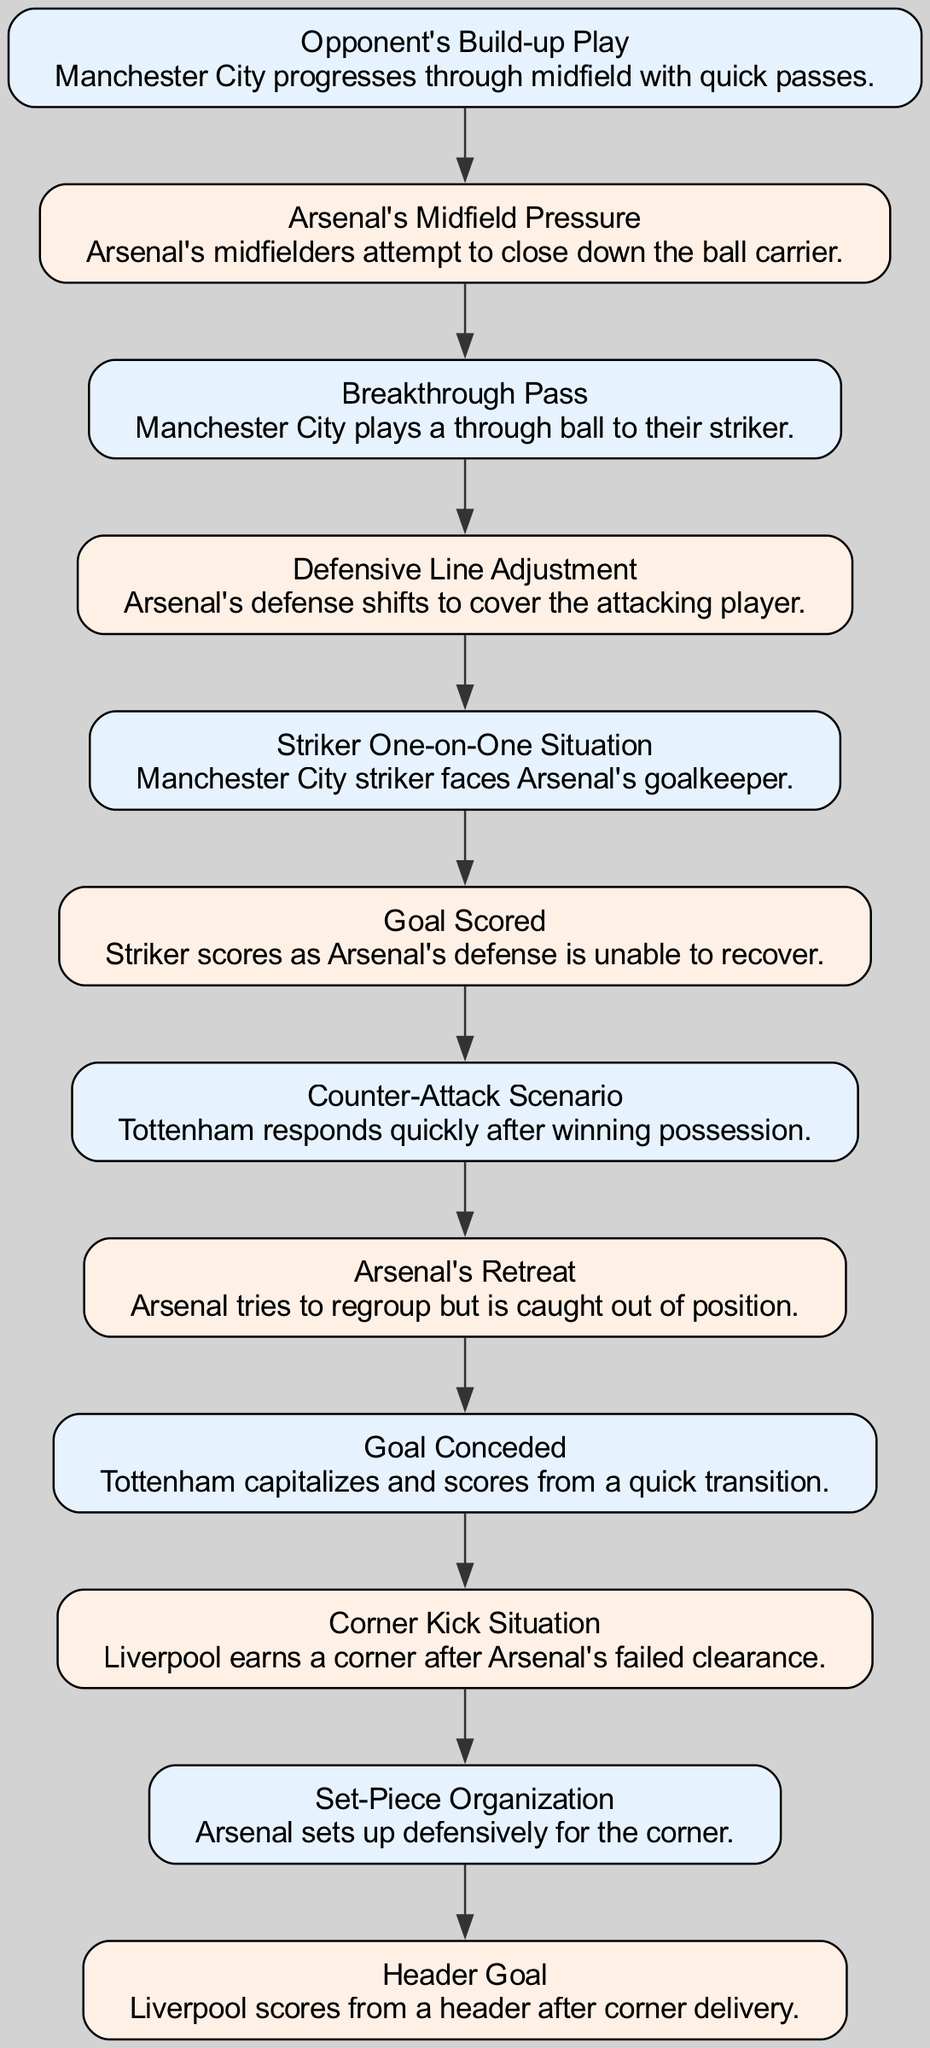What's the first event leading to a goal conceded by Arsenal? The first event in the diagram is "Opponent's Build-up Play," where Manchester City progresses through midfield with quick passes. This indicates the beginning of the sequence of events that lead to a goal.
Answer: Opponent's Build-up Play How many events are shown in the diagram? Counting the events in the sequence, we find 10 distinct events listed in the diagram, detailing the actions leading to goals conceded by Arsenal.
Answer: 10 What action does Arsenal take in response to Manchester City's build-up play? Arsenal's response to Manchester City's build-up is "Arsenal's Midfield Pressure," where their midfielders attempt to close down the ball carrier. This shows their initial attempt to defend against the attack.
Answer: Arsenal's Midfield Pressure What event occurs immediately after the "Breakthrough Pass"? The event that follows "Breakthrough Pass" is "Defensive Line Adjustment," indicating Arsenal's defense shift to cover the attacking player after Manchester City plays a through ball.
Answer: Defensive Line Adjustment What was the consequence of the "Striker One-on-One Situation"? The consequence was a "Goal Scored," meaning that the Manchester City striker scored against Arsenal as the defense failed to recover in time to stop him.
Answer: Goal Scored Which team capitalized on Arsenal's defensive errors after a counter-attack? Tottenham is the team that capitalized on Arsenal's defensive mistakes during a "Counter-Attack Scenario," catching Arsenal out of position to score.
Answer: Tottenham Which type of goal did Liverpool score after a corner kick? Liverpool scored a "Header Goal" after a corner delivery, demonstrating the effectiveness of set-pieces against Arsenal's defense.
Answer: Header Goal What does the "Set-Piece Organization" event indicate about Arsenal's preparation? The "Set-Piece Organization" event indicates that Arsenal attempted to prepare defensively for the upcoming corner kick in effort to prevent a goal from set pieces.
Answer: Set-Piece Organization What event occurs before the Tottenham goal? Before the Tottenham goal, the event “Arsenal’s Retreat” takes place, where Arsenal tries to regroup but is caught out of position, leading to the concession of the goal.
Answer: Arsenal's Retreat 